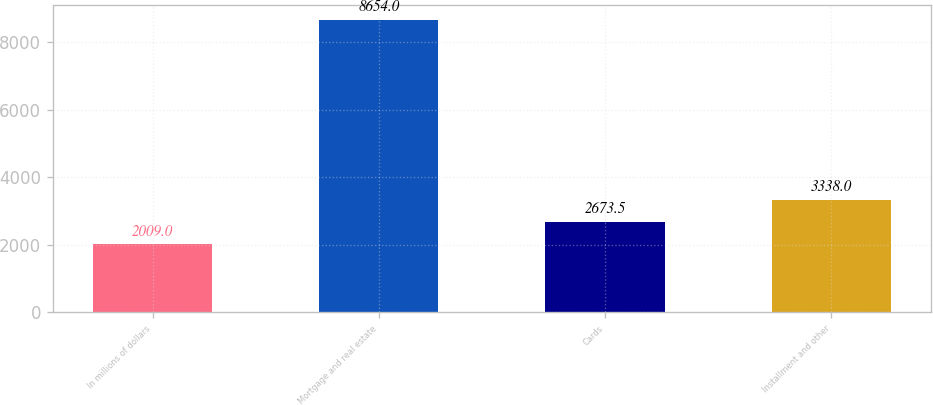Convert chart. <chart><loc_0><loc_0><loc_500><loc_500><bar_chart><fcel>In millions of dollars<fcel>Mortgage and real estate<fcel>Cards<fcel>Installment and other<nl><fcel>2009<fcel>8654<fcel>2673.5<fcel>3338<nl></chart> 